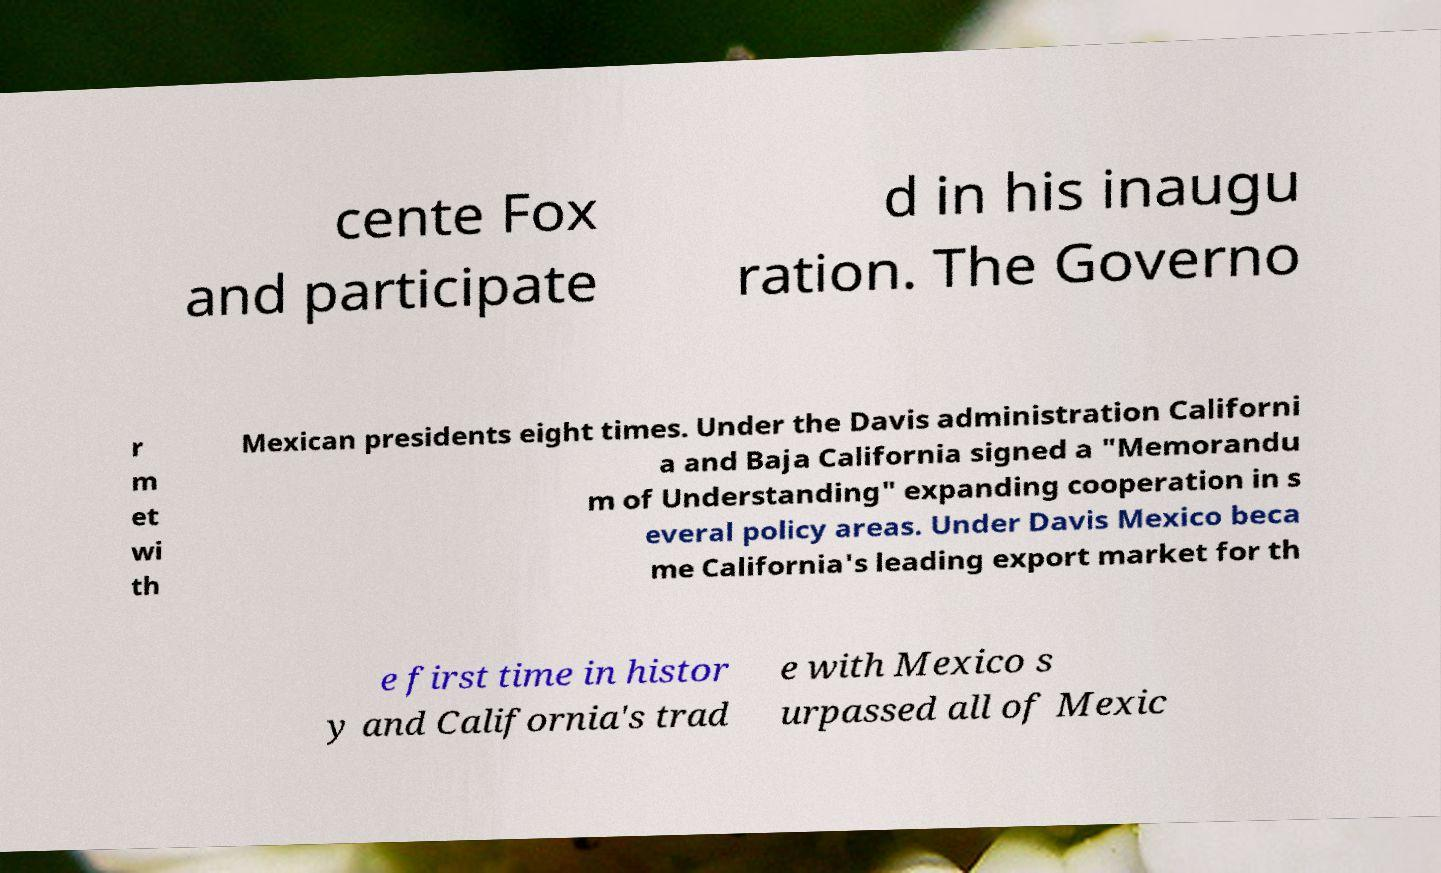Could you extract and type out the text from this image? cente Fox and participate d in his inaugu ration. The Governo r m et wi th Mexican presidents eight times. Under the Davis administration Californi a and Baja California signed a "Memorandu m of Understanding" expanding cooperation in s everal policy areas. Under Davis Mexico beca me California's leading export market for th e first time in histor y and California's trad e with Mexico s urpassed all of Mexic 